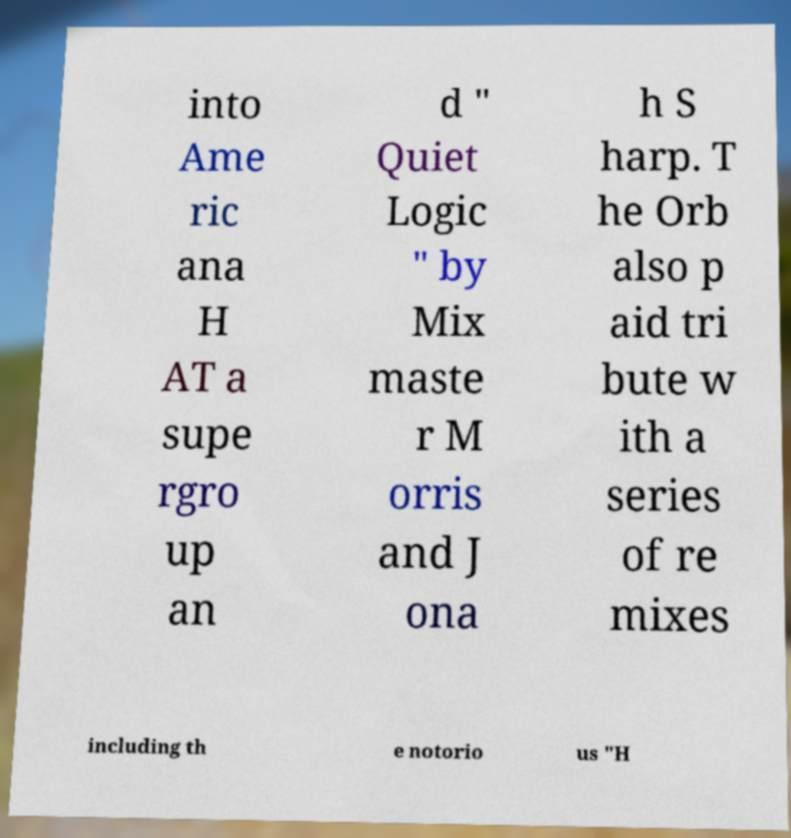Please read and relay the text visible in this image. What does it say? into Ame ric ana H AT a supe rgro up an d " Quiet Logic " by Mix maste r M orris and J ona h S harp. T he Orb also p aid tri bute w ith a series of re mixes including th e notorio us "H 